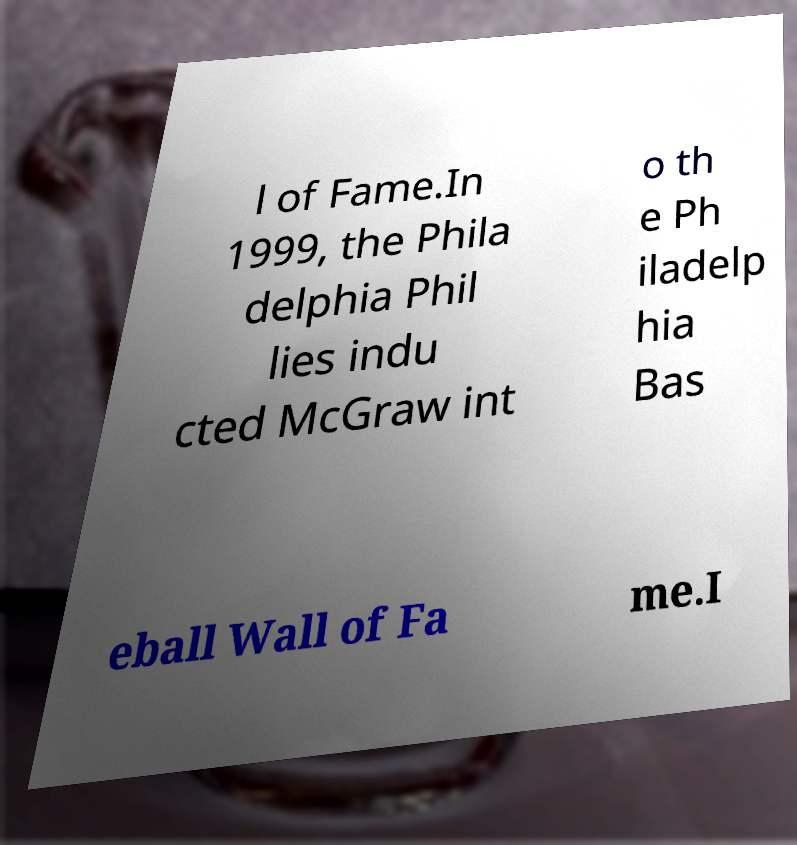Could you extract and type out the text from this image? l of Fame.In 1999, the Phila delphia Phil lies indu cted McGraw int o th e Ph iladelp hia Bas eball Wall of Fa me.I 